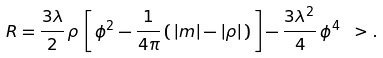<formula> <loc_0><loc_0><loc_500><loc_500>R = \frac { 3 \lambda } { 2 } \, \rho \, \left [ \, \phi ^ { 2 } - \frac { 1 } { 4 \pi } \, ( \, | m | - | \rho | \, ) \, \right ] - \frac { 3 \lambda ^ { 2 } } { 4 } \, \phi ^ { 4 } \ > .</formula> 